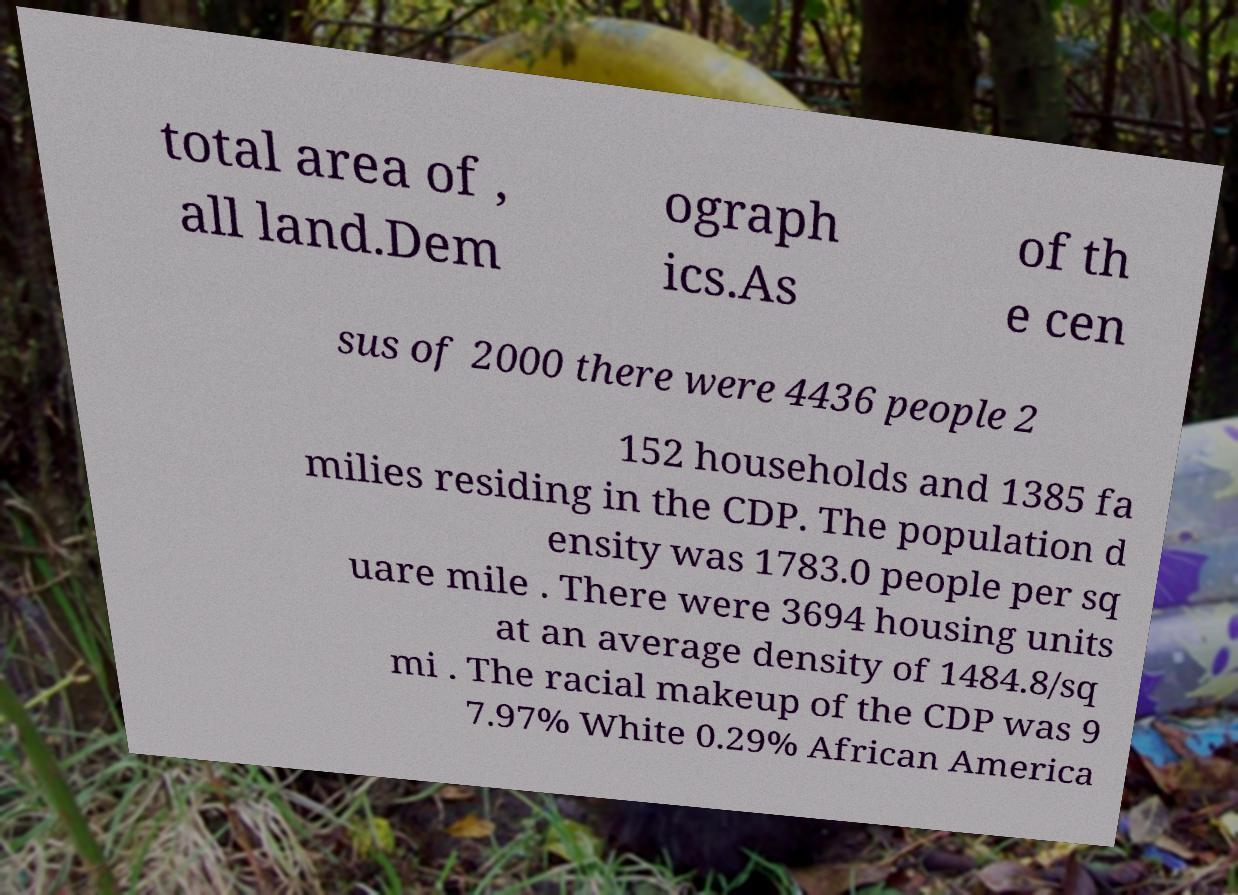For documentation purposes, I need the text within this image transcribed. Could you provide that? total area of , all land.Dem ograph ics.As of th e cen sus of 2000 there were 4436 people 2 152 households and 1385 fa milies residing in the CDP. The population d ensity was 1783.0 people per sq uare mile . There were 3694 housing units at an average density of 1484.8/sq mi . The racial makeup of the CDP was 9 7.97% White 0.29% African America 